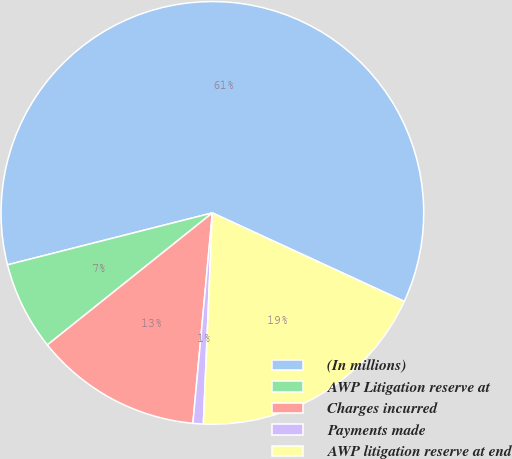Convert chart to OTSL. <chart><loc_0><loc_0><loc_500><loc_500><pie_chart><fcel>(In millions)<fcel>AWP Litigation reserve at<fcel>Charges incurred<fcel>Payments made<fcel>AWP litigation reserve at end<nl><fcel>60.83%<fcel>6.79%<fcel>12.79%<fcel>0.79%<fcel>18.8%<nl></chart> 